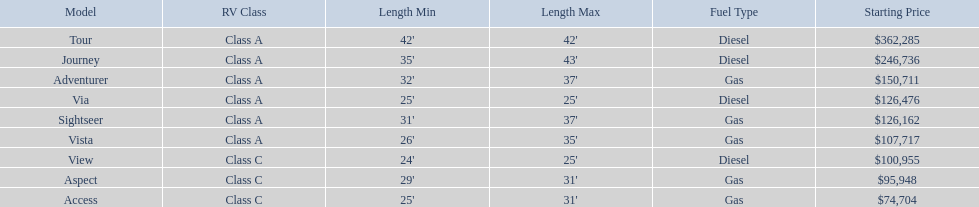Which models are manufactured by winnebago industries? Tour, Journey, Adventurer, Via, Sightseer, Vista, View, Aspect, Access. What type of fuel does each model require? Diesel, Diesel, Gas, Diesel, Gas, Gas, Diesel, Gas, Gas. And between the tour and aspect, which runs on diesel? Tour. 